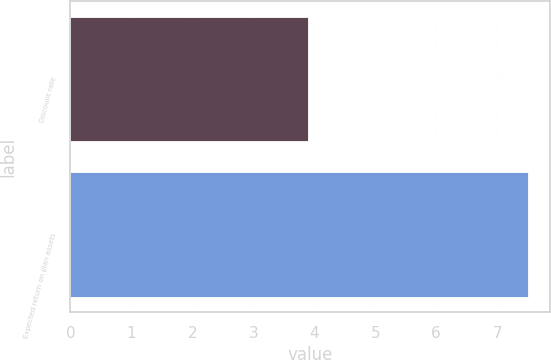Convert chart. <chart><loc_0><loc_0><loc_500><loc_500><bar_chart><fcel>Discount rate<fcel>Expected return on plan assets<nl><fcel>3.9<fcel>7.5<nl></chart> 